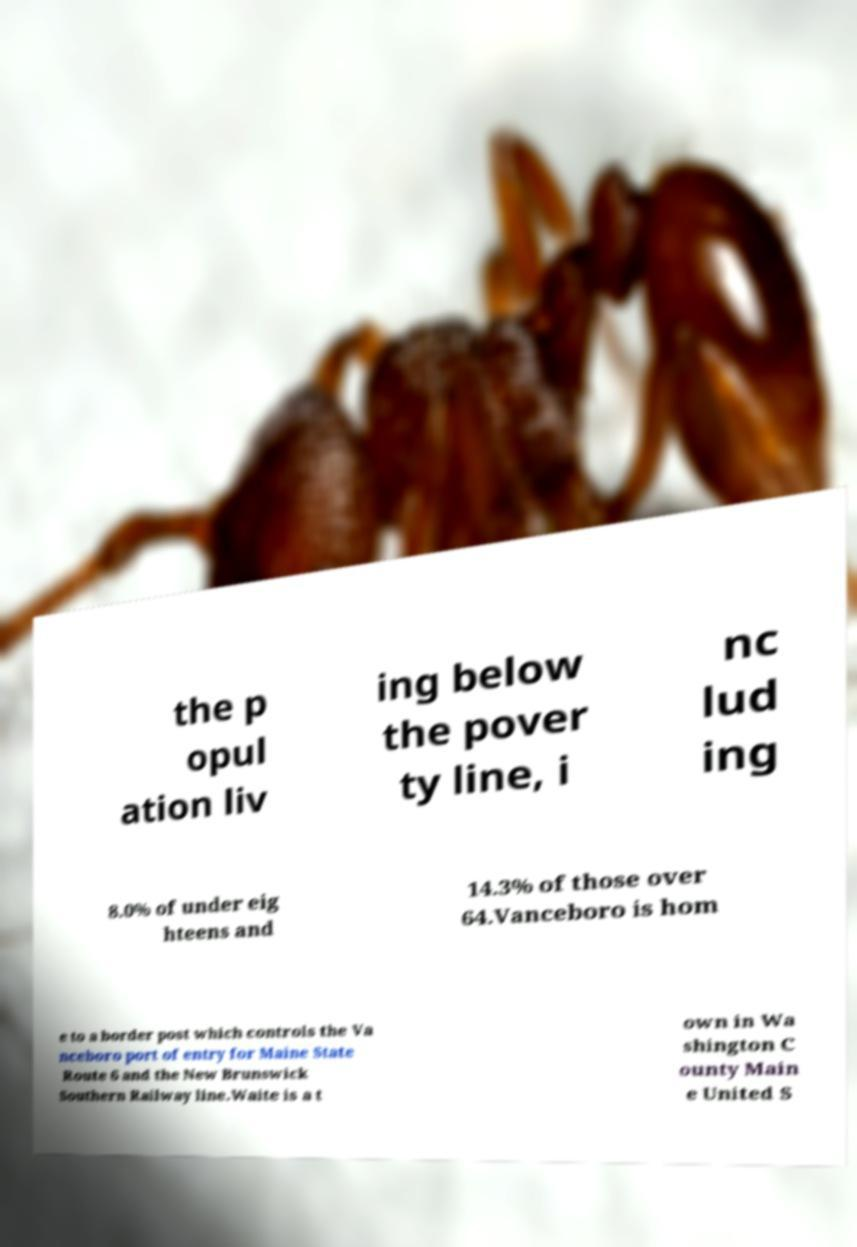Please read and relay the text visible in this image. What does it say? the p opul ation liv ing below the pover ty line, i nc lud ing 8.0% of under eig hteens and 14.3% of those over 64.Vanceboro is hom e to a border post which controls the Va nceboro port of entry for Maine State Route 6 and the New Brunswick Southern Railway line.Waite is a t own in Wa shington C ounty Main e United S 